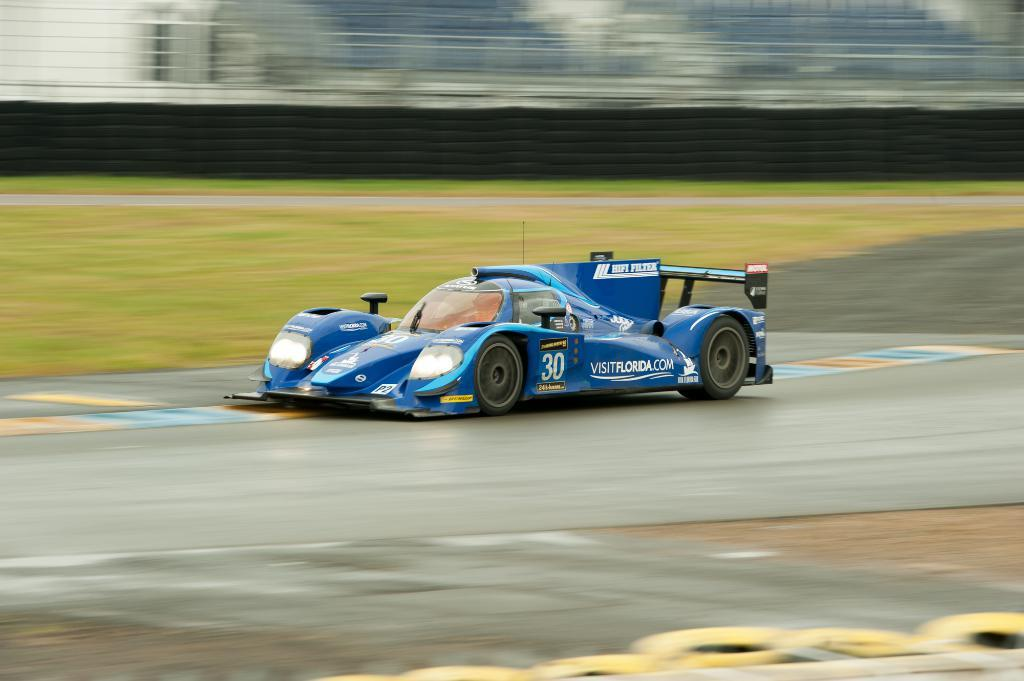What is the main subject of the image? There is a vehicle on the road in the image. What can be seen in the background of the image? The background of the image includes the ground, a wall, and some objects. How would you describe the appearance of the background? The background appears blurry. What type of flesh can be seen on the beds in the image? There are no beds or flesh present in the image; it features a vehicle on the road with a blurry background. 